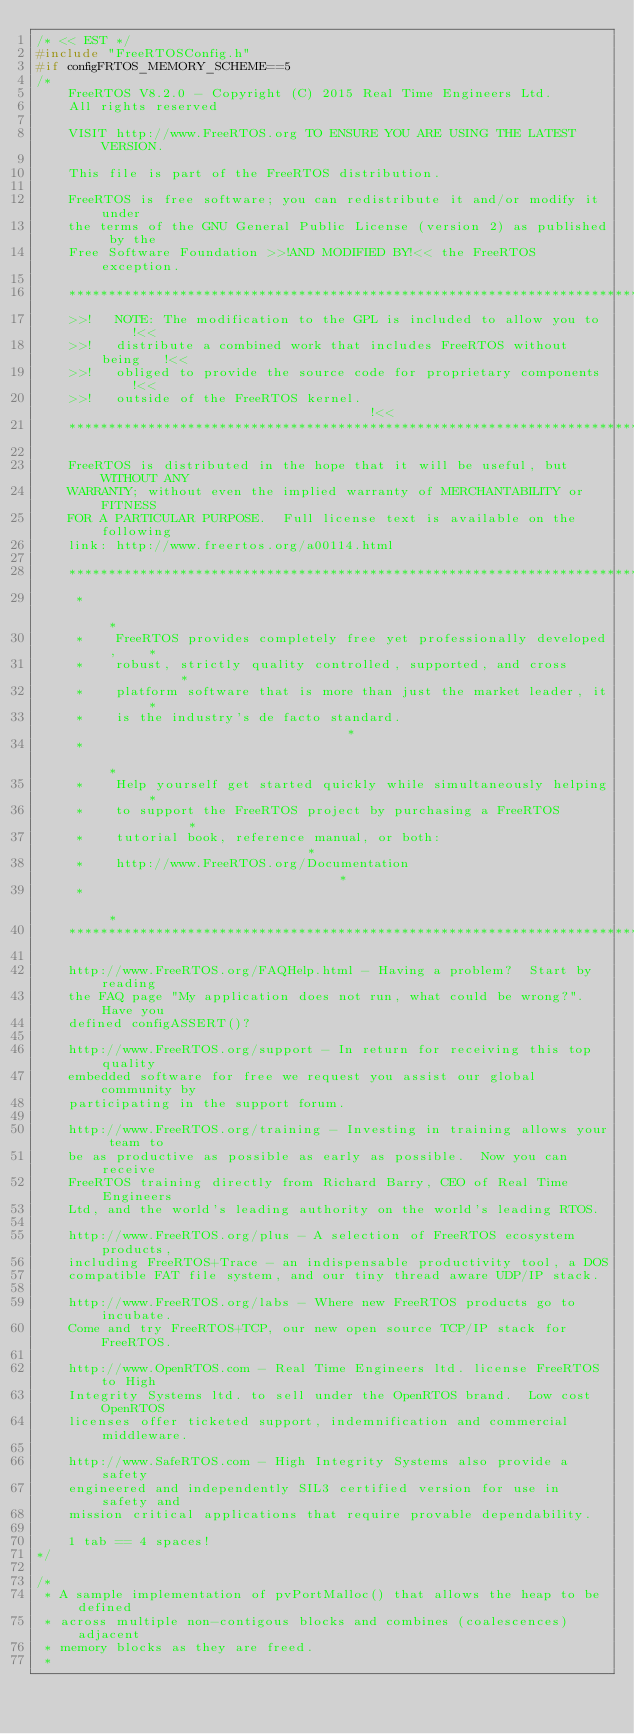<code> <loc_0><loc_0><loc_500><loc_500><_C_>/* << EST */
#include "FreeRTOSConfig.h"
#if configFRTOS_MEMORY_SCHEME==5
/*
    FreeRTOS V8.2.0 - Copyright (C) 2015 Real Time Engineers Ltd.
    All rights reserved

    VISIT http://www.FreeRTOS.org TO ENSURE YOU ARE USING THE LATEST VERSION.

    This file is part of the FreeRTOS distribution.

    FreeRTOS is free software; you can redistribute it and/or modify it under
    the terms of the GNU General Public License (version 2) as published by the
    Free Software Foundation >>!AND MODIFIED BY!<< the FreeRTOS exception.

	***************************************************************************
    >>!   NOTE: The modification to the GPL is included to allow you to     !<<
    >>!   distribute a combined work that includes FreeRTOS without being   !<<
    >>!   obliged to provide the source code for proprietary components     !<<
    >>!   outside of the FreeRTOS kernel.                                   !<<
	***************************************************************************

    FreeRTOS is distributed in the hope that it will be useful, but WITHOUT ANY
    WARRANTY; without even the implied warranty of MERCHANTABILITY or FITNESS
    FOR A PARTICULAR PURPOSE.  Full license text is available on the following
    link: http://www.freertos.org/a00114.html

    ***************************************************************************
     *                                                                       *
     *    FreeRTOS provides completely free yet professionally developed,    *
     *    robust, strictly quality controlled, supported, and cross          *
     *    platform software that is more than just the market leader, it     *
     *    is the industry's de facto standard.                               *
     *                                                                       *
     *    Help yourself get started quickly while simultaneously helping     *
     *    to support the FreeRTOS project by purchasing a FreeRTOS           *
     *    tutorial book, reference manual, or both:                          *
     *    http://www.FreeRTOS.org/Documentation                              *
     *                                                                       *
    ***************************************************************************

    http://www.FreeRTOS.org/FAQHelp.html - Having a problem?  Start by reading
	the FAQ page "My application does not run, what could be wrong?".  Have you
	defined configASSERT()?

	http://www.FreeRTOS.org/support - In return for receiving this top quality
	embedded software for free we request you assist our global community by
	participating in the support forum.

	http://www.FreeRTOS.org/training - Investing in training allows your team to
	be as productive as possible as early as possible.  Now you can receive
	FreeRTOS training directly from Richard Barry, CEO of Real Time Engineers
	Ltd, and the world's leading authority on the world's leading RTOS.

    http://www.FreeRTOS.org/plus - A selection of FreeRTOS ecosystem products,
    including FreeRTOS+Trace - an indispensable productivity tool, a DOS
    compatible FAT file system, and our tiny thread aware UDP/IP stack.

    http://www.FreeRTOS.org/labs - Where new FreeRTOS products go to incubate.
    Come and try FreeRTOS+TCP, our new open source TCP/IP stack for FreeRTOS.

    http://www.OpenRTOS.com - Real Time Engineers ltd. license FreeRTOS to High
    Integrity Systems ltd. to sell under the OpenRTOS brand.  Low cost OpenRTOS
    licenses offer ticketed support, indemnification and commercial middleware.

    http://www.SafeRTOS.com - High Integrity Systems also provide a safety
    engineered and independently SIL3 certified version for use in safety and
    mission critical applications that require provable dependability.

    1 tab == 4 spaces!
*/

/*
 * A sample implementation of pvPortMalloc() that allows the heap to be defined
 * across multiple non-contigous blocks and combines (coalescences) adjacent
 * memory blocks as they are freed.
 *</code> 